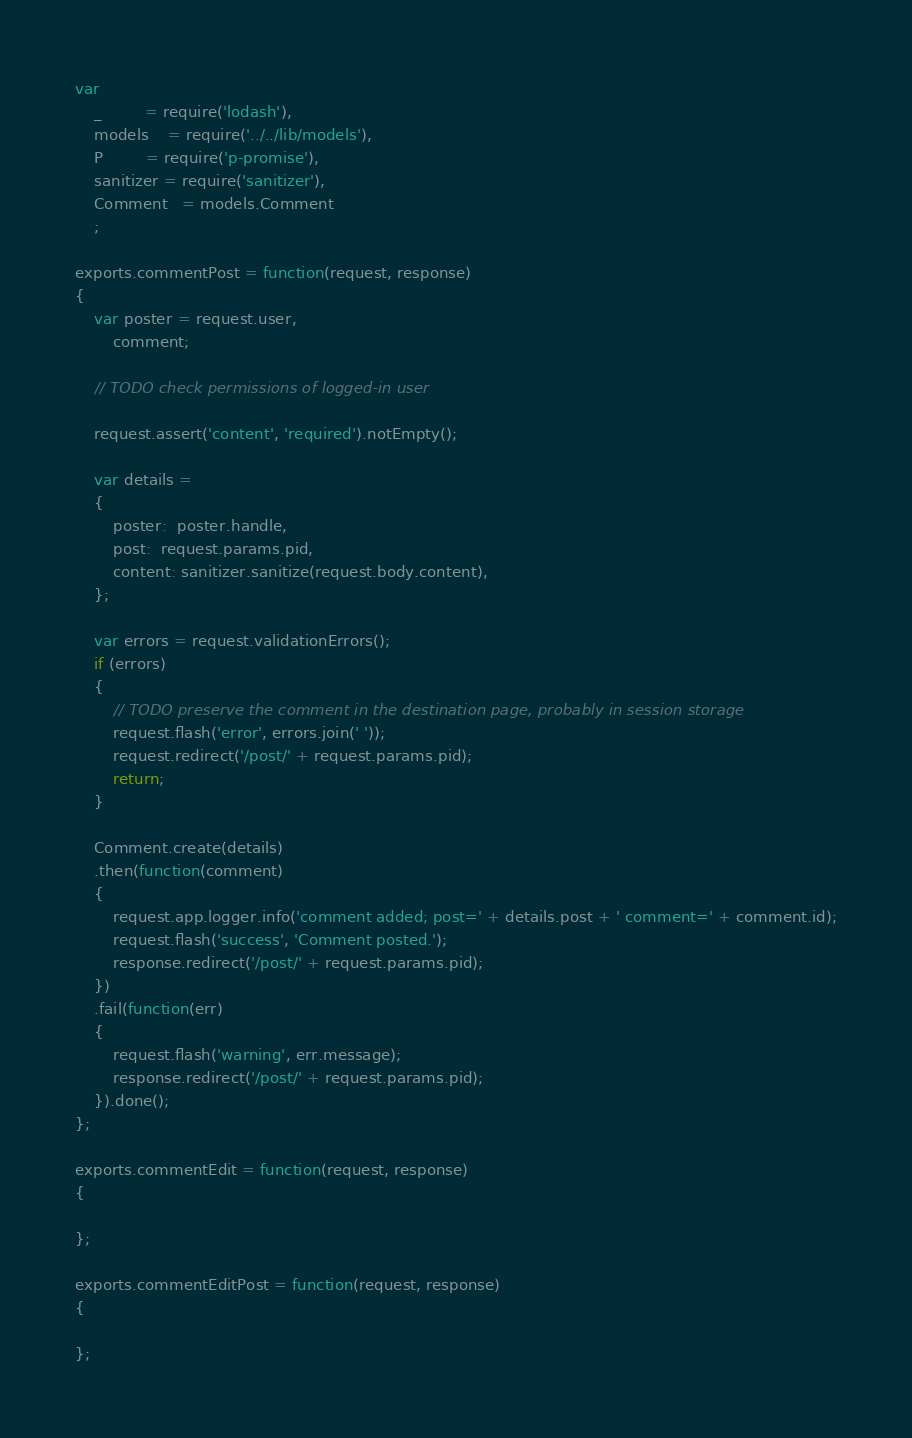Convert code to text. <code><loc_0><loc_0><loc_500><loc_500><_JavaScript_>var
	_         = require('lodash'),
	models    = require('../../lib/models'),
	P         = require('p-promise'),
	sanitizer = require('sanitizer'),
	Comment   = models.Comment
	;

exports.commentPost = function(request, response)
{
	var poster = request.user,
		comment;

	// TODO check permissions of logged-in user

	request.assert('content', 'required').notEmpty();

	var details =
	{
		poster:  poster.handle,
		post:  request.params.pid,
		content: sanitizer.sanitize(request.body.content),
	};

	var errors = request.validationErrors();
	if (errors)
	{
		// TODO preserve the comment in the destination page, probably in session storage
		request.flash('error', errors.join(' '));
		request.redirect('/post/' + request.params.pid);
		return;
	}

	Comment.create(details)
	.then(function(comment)
	{
		request.app.logger.info('comment added; post=' + details.post + ' comment=' + comment.id);
		request.flash('success', 'Comment posted.');
		response.redirect('/post/' + request.params.pid);
	})
	.fail(function(err)
	{
		request.flash('warning', err.message);
		response.redirect('/post/' + request.params.pid);
	}).done();
};

exports.commentEdit = function(request, response)
{

};

exports.commentEditPost = function(request, response)
{

};

</code> 